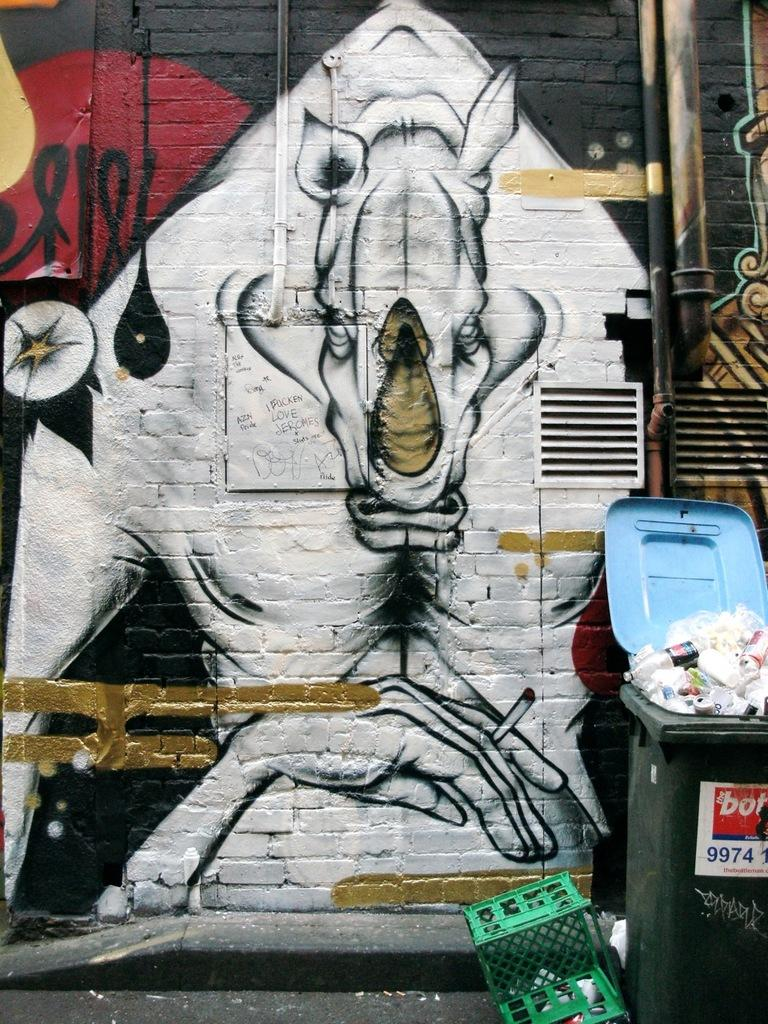<image>
Render a clear and concise summary of the photo. A picture of a rhino on a wall with an open bin displaying the number 9974 